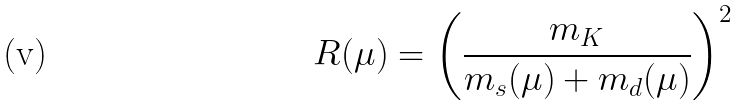<formula> <loc_0><loc_0><loc_500><loc_500>R ( \mu ) = \left ( \frac { m _ { K } } { m _ { s } ( \mu ) + m _ { d } ( \mu ) } \right ) ^ { 2 }</formula> 